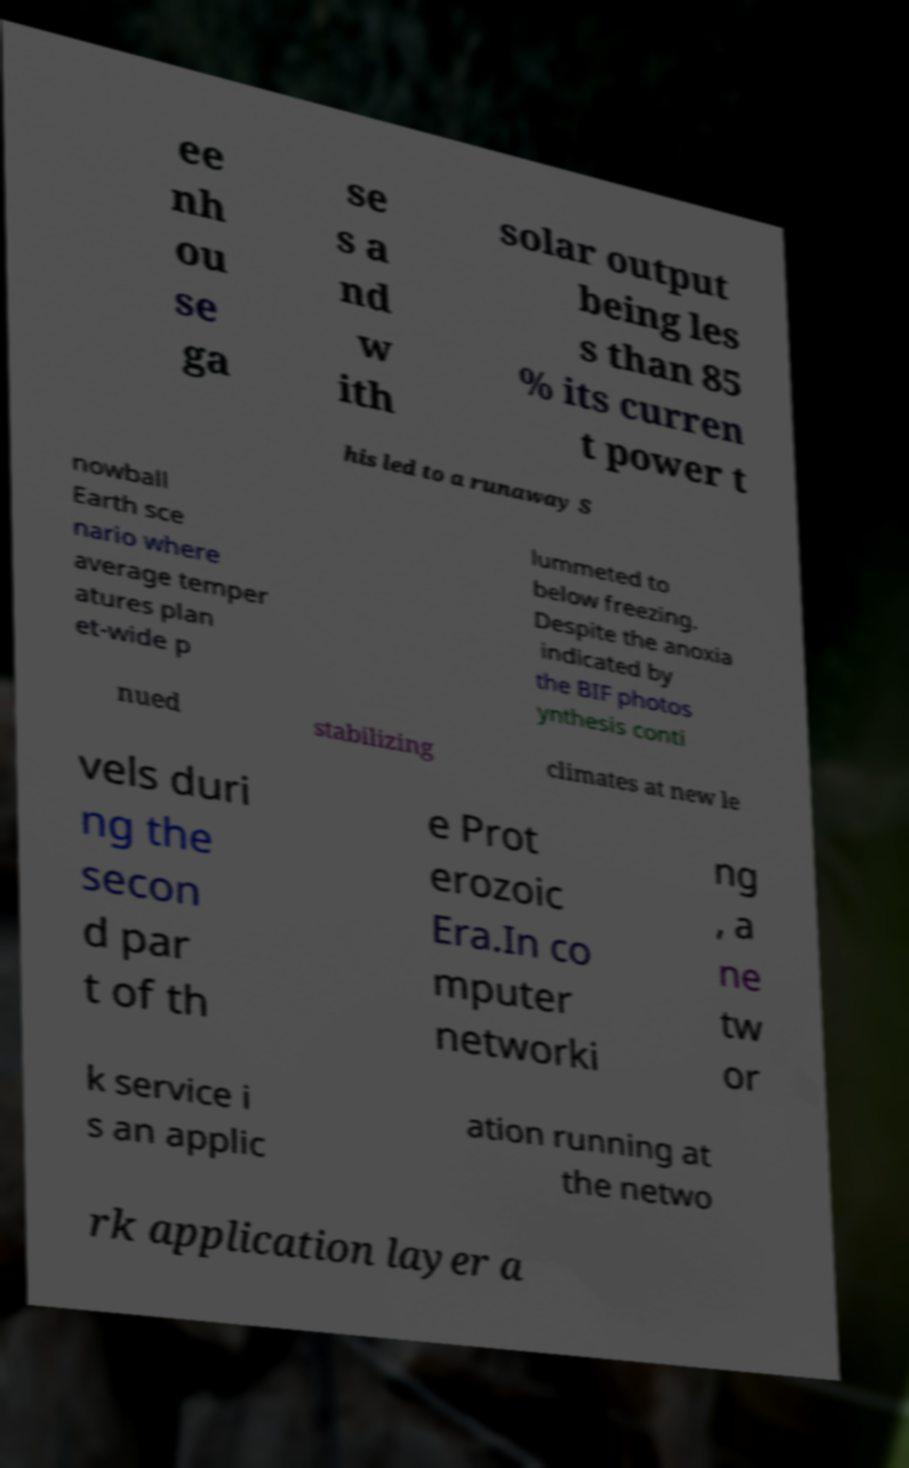For documentation purposes, I need the text within this image transcribed. Could you provide that? ee nh ou se ga se s a nd w ith solar output being les s than 85 % its curren t power t his led to a runaway S nowball Earth sce nario where average temper atures plan et-wide p lummeted to below freezing. Despite the anoxia indicated by the BIF photos ynthesis conti nued stabilizing climates at new le vels duri ng the secon d par t of th e Prot erozoic Era.In co mputer networki ng , a ne tw or k service i s an applic ation running at the netwo rk application layer a 